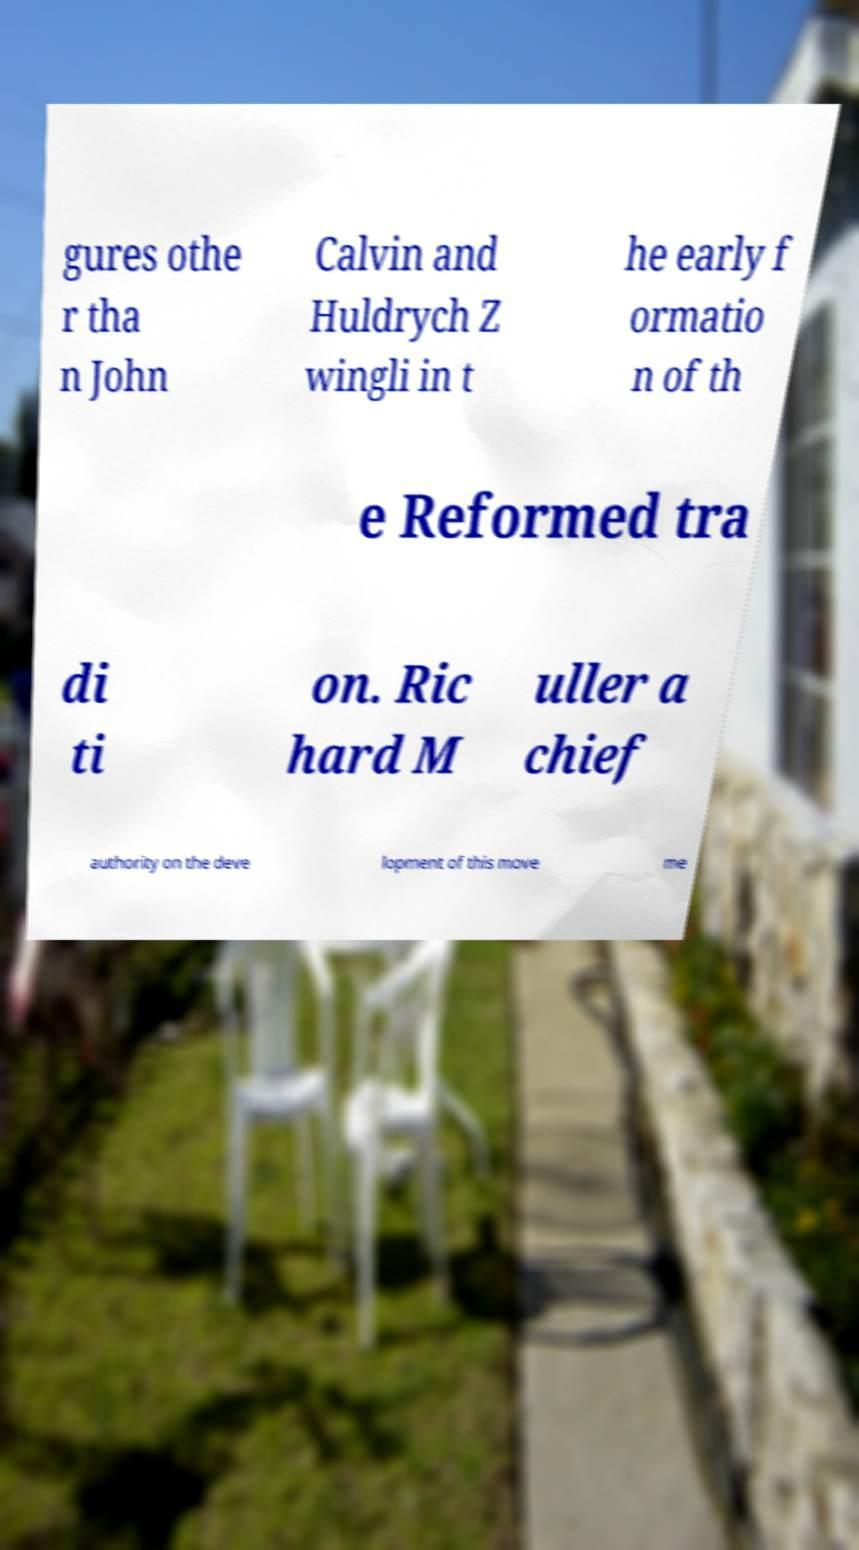Please identify and transcribe the text found in this image. gures othe r tha n John Calvin and Huldrych Z wingli in t he early f ormatio n of th e Reformed tra di ti on. Ric hard M uller a chief authority on the deve lopment of this move me 